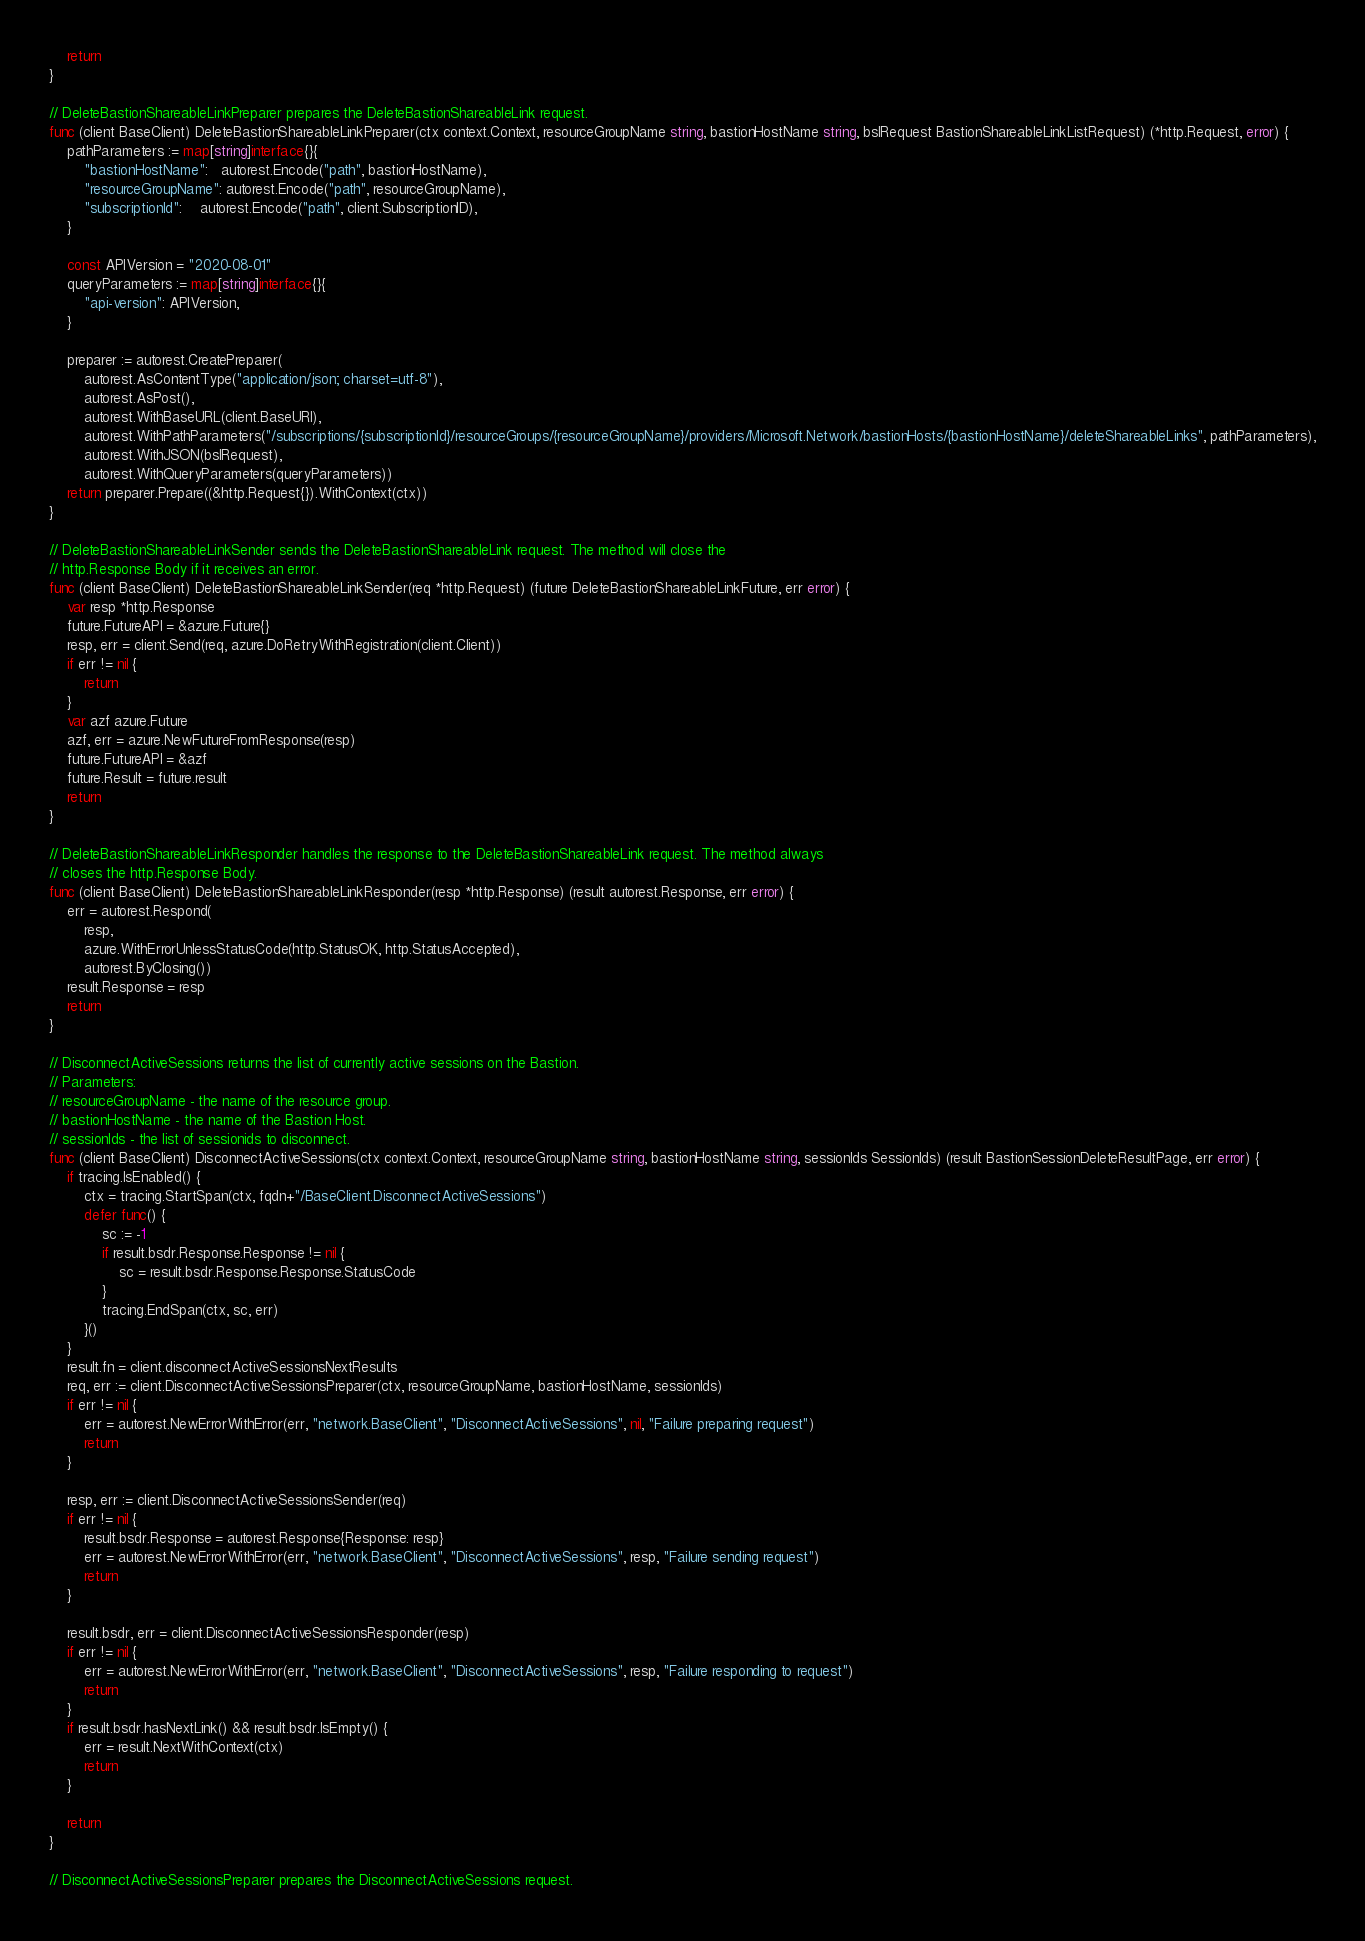Convert code to text. <code><loc_0><loc_0><loc_500><loc_500><_Go_>	return
}

// DeleteBastionShareableLinkPreparer prepares the DeleteBastionShareableLink request.
func (client BaseClient) DeleteBastionShareableLinkPreparer(ctx context.Context, resourceGroupName string, bastionHostName string, bslRequest BastionShareableLinkListRequest) (*http.Request, error) {
	pathParameters := map[string]interface{}{
		"bastionHostName":   autorest.Encode("path", bastionHostName),
		"resourceGroupName": autorest.Encode("path", resourceGroupName),
		"subscriptionId":    autorest.Encode("path", client.SubscriptionID),
	}

	const APIVersion = "2020-08-01"
	queryParameters := map[string]interface{}{
		"api-version": APIVersion,
	}

	preparer := autorest.CreatePreparer(
		autorest.AsContentType("application/json; charset=utf-8"),
		autorest.AsPost(),
		autorest.WithBaseURL(client.BaseURI),
		autorest.WithPathParameters("/subscriptions/{subscriptionId}/resourceGroups/{resourceGroupName}/providers/Microsoft.Network/bastionHosts/{bastionHostName}/deleteShareableLinks", pathParameters),
		autorest.WithJSON(bslRequest),
		autorest.WithQueryParameters(queryParameters))
	return preparer.Prepare((&http.Request{}).WithContext(ctx))
}

// DeleteBastionShareableLinkSender sends the DeleteBastionShareableLink request. The method will close the
// http.Response Body if it receives an error.
func (client BaseClient) DeleteBastionShareableLinkSender(req *http.Request) (future DeleteBastionShareableLinkFuture, err error) {
	var resp *http.Response
	future.FutureAPI = &azure.Future{}
	resp, err = client.Send(req, azure.DoRetryWithRegistration(client.Client))
	if err != nil {
		return
	}
	var azf azure.Future
	azf, err = azure.NewFutureFromResponse(resp)
	future.FutureAPI = &azf
	future.Result = future.result
	return
}

// DeleteBastionShareableLinkResponder handles the response to the DeleteBastionShareableLink request. The method always
// closes the http.Response Body.
func (client BaseClient) DeleteBastionShareableLinkResponder(resp *http.Response) (result autorest.Response, err error) {
	err = autorest.Respond(
		resp,
		azure.WithErrorUnlessStatusCode(http.StatusOK, http.StatusAccepted),
		autorest.ByClosing())
	result.Response = resp
	return
}

// DisconnectActiveSessions returns the list of currently active sessions on the Bastion.
// Parameters:
// resourceGroupName - the name of the resource group.
// bastionHostName - the name of the Bastion Host.
// sessionIds - the list of sessionids to disconnect.
func (client BaseClient) DisconnectActiveSessions(ctx context.Context, resourceGroupName string, bastionHostName string, sessionIds SessionIds) (result BastionSessionDeleteResultPage, err error) {
	if tracing.IsEnabled() {
		ctx = tracing.StartSpan(ctx, fqdn+"/BaseClient.DisconnectActiveSessions")
		defer func() {
			sc := -1
			if result.bsdr.Response.Response != nil {
				sc = result.bsdr.Response.Response.StatusCode
			}
			tracing.EndSpan(ctx, sc, err)
		}()
	}
	result.fn = client.disconnectActiveSessionsNextResults
	req, err := client.DisconnectActiveSessionsPreparer(ctx, resourceGroupName, bastionHostName, sessionIds)
	if err != nil {
		err = autorest.NewErrorWithError(err, "network.BaseClient", "DisconnectActiveSessions", nil, "Failure preparing request")
		return
	}

	resp, err := client.DisconnectActiveSessionsSender(req)
	if err != nil {
		result.bsdr.Response = autorest.Response{Response: resp}
		err = autorest.NewErrorWithError(err, "network.BaseClient", "DisconnectActiveSessions", resp, "Failure sending request")
		return
	}

	result.bsdr, err = client.DisconnectActiveSessionsResponder(resp)
	if err != nil {
		err = autorest.NewErrorWithError(err, "network.BaseClient", "DisconnectActiveSessions", resp, "Failure responding to request")
		return
	}
	if result.bsdr.hasNextLink() && result.bsdr.IsEmpty() {
		err = result.NextWithContext(ctx)
		return
	}

	return
}

// DisconnectActiveSessionsPreparer prepares the DisconnectActiveSessions request.</code> 